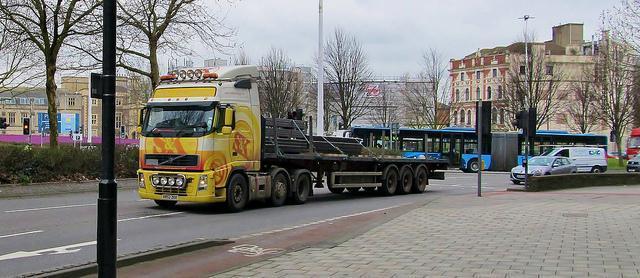How many trees are in the far left?
Give a very brief answer. 2. How many umbrellas can be seen?
Give a very brief answer. 0. 